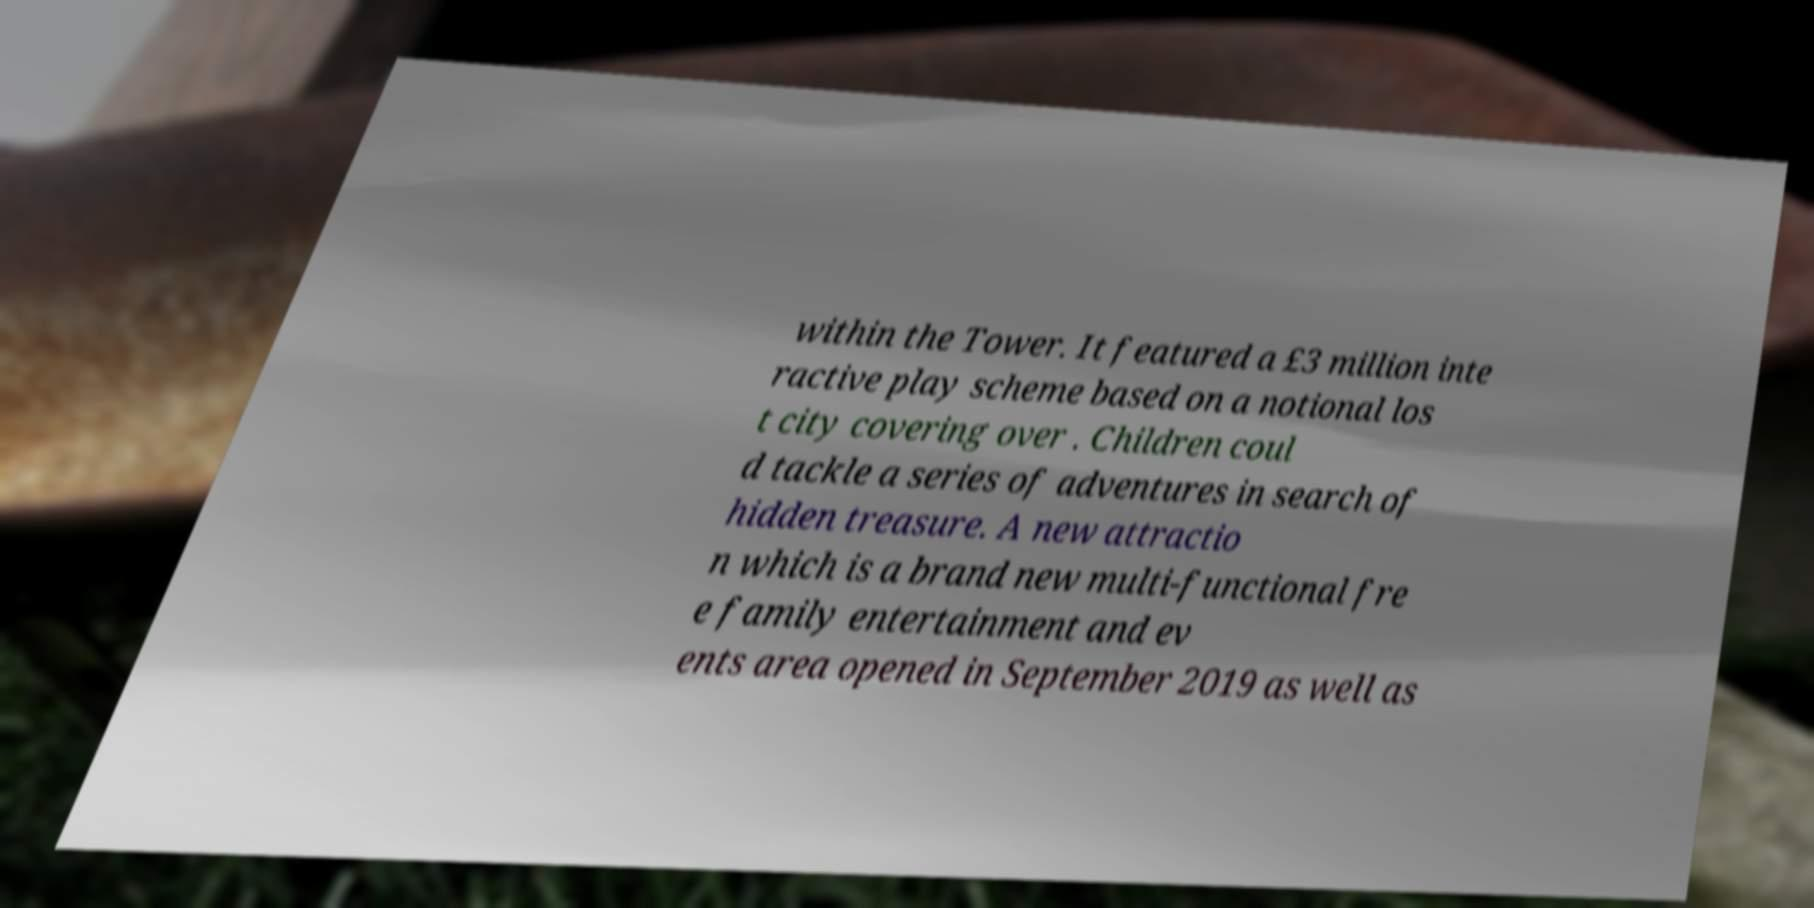I need the written content from this picture converted into text. Can you do that? within the Tower. It featured a £3 million inte ractive play scheme based on a notional los t city covering over . Children coul d tackle a series of adventures in search of hidden treasure. A new attractio n which is a brand new multi-functional fre e family entertainment and ev ents area opened in September 2019 as well as 